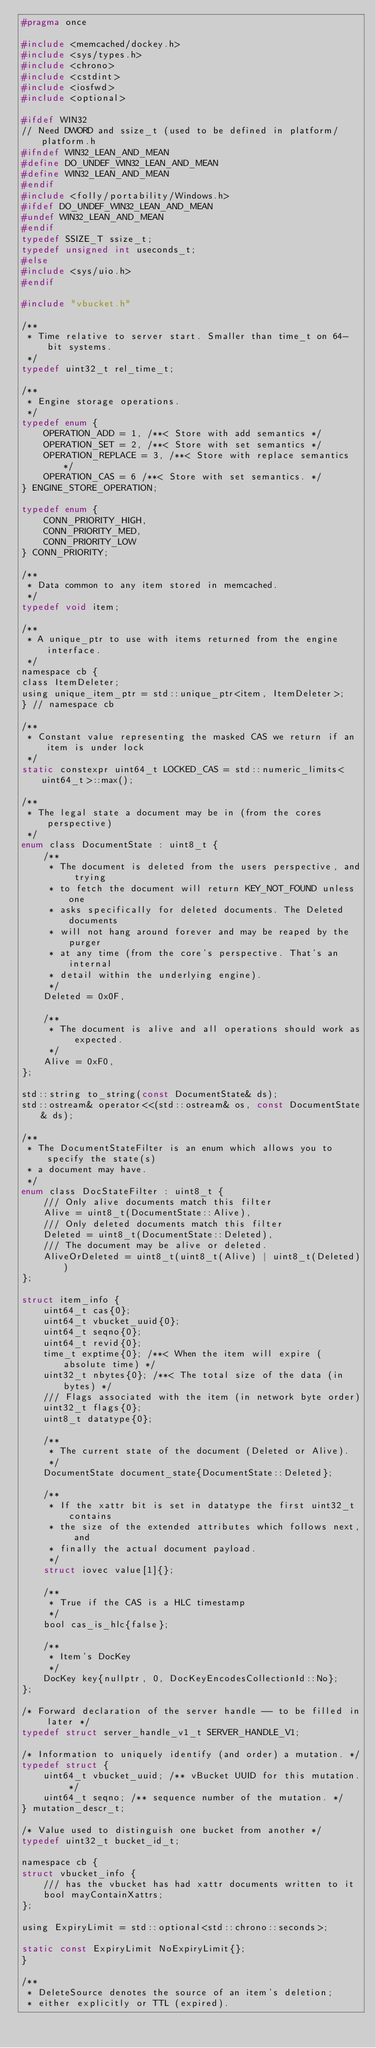Convert code to text. <code><loc_0><loc_0><loc_500><loc_500><_C_>#pragma once

#include <memcached/dockey.h>
#include <sys/types.h>
#include <chrono>
#include <cstdint>
#include <iosfwd>
#include <optional>

#ifdef WIN32
// Need DWORD and ssize_t (used to be defined in platform/platform.h
#ifndef WIN32_LEAN_AND_MEAN
#define DO_UNDEF_WIN32_LEAN_AND_MEAN
#define WIN32_LEAN_AND_MEAN
#endif
#include <folly/portability/Windows.h>
#ifdef DO_UNDEF_WIN32_LEAN_AND_MEAN
#undef WIN32_LEAN_AND_MEAN
#endif
typedef SSIZE_T ssize_t;
typedef unsigned int useconds_t;
#else
#include <sys/uio.h>
#endif

#include "vbucket.h"

/**
 * Time relative to server start. Smaller than time_t on 64-bit systems.
 */
typedef uint32_t rel_time_t;

/**
 * Engine storage operations.
 */
typedef enum {
    OPERATION_ADD = 1, /**< Store with add semantics */
    OPERATION_SET = 2, /**< Store with set semantics */
    OPERATION_REPLACE = 3, /**< Store with replace semantics */
    OPERATION_CAS = 6 /**< Store with set semantics. */
} ENGINE_STORE_OPERATION;

typedef enum {
    CONN_PRIORITY_HIGH,
    CONN_PRIORITY_MED,
    CONN_PRIORITY_LOW
} CONN_PRIORITY;

/**
 * Data common to any item stored in memcached.
 */
typedef void item;

/**
 * A unique_ptr to use with items returned from the engine interface.
 */
namespace cb {
class ItemDeleter;
using unique_item_ptr = std::unique_ptr<item, ItemDeleter>;
} // namespace cb

/**
 * Constant value representing the masked CAS we return if an item is under lock
 */
static constexpr uint64_t LOCKED_CAS = std::numeric_limits<uint64_t>::max();

/**
 * The legal state a document may be in (from the cores perspective)
 */
enum class DocumentState : uint8_t {
    /**
     * The document is deleted from the users perspective, and trying
     * to fetch the document will return KEY_NOT_FOUND unless one
     * asks specifically for deleted documents. The Deleted documents
     * will not hang around forever and may be reaped by the purger
     * at any time (from the core's perspective. That's an internal
     * detail within the underlying engine).
     */
    Deleted = 0x0F,

    /**
     * The document is alive and all operations should work as expected.
     */
    Alive = 0xF0,
};

std::string to_string(const DocumentState& ds);
std::ostream& operator<<(std::ostream& os, const DocumentState& ds);

/**
 * The DocumentStateFilter is an enum which allows you to specify the state(s)
 * a document may have.
 */
enum class DocStateFilter : uint8_t {
    /// Only alive documents match this filter
    Alive = uint8_t(DocumentState::Alive),
    /// Only deleted documents match this filter
    Deleted = uint8_t(DocumentState::Deleted),
    /// The document may be alive or deleted.
    AliveOrDeleted = uint8_t(uint8_t(Alive) | uint8_t(Deleted))
};

struct item_info {
    uint64_t cas{0};
    uint64_t vbucket_uuid{0};
    uint64_t seqno{0};
    uint64_t revid{0};
    time_t exptime{0}; /**< When the item will expire (absolute time) */
    uint32_t nbytes{0}; /**< The total size of the data (in bytes) */
    /// Flags associated with the item (in network byte order)
    uint32_t flags{0};
    uint8_t datatype{0};

    /**
     * The current state of the document (Deleted or Alive).
     */
    DocumentState document_state{DocumentState::Deleted};

    /**
     * If the xattr bit is set in datatype the first uint32_t contains
     * the size of the extended attributes which follows next, and
     * finally the actual document payload.
     */
    struct iovec value[1]{};

    /**
     * True if the CAS is a HLC timestamp
     */
    bool cas_is_hlc{false};

    /**
     * Item's DocKey
     */
    DocKey key{nullptr, 0, DocKeyEncodesCollectionId::No};
};

/* Forward declaration of the server handle -- to be filled in later */
typedef struct server_handle_v1_t SERVER_HANDLE_V1;

/* Information to uniquely identify (and order) a mutation. */
typedef struct {
    uint64_t vbucket_uuid; /** vBucket UUID for this mutation. */
    uint64_t seqno; /** sequence number of the mutation. */
} mutation_descr_t;

/* Value used to distinguish one bucket from another */
typedef uint32_t bucket_id_t;

namespace cb {
struct vbucket_info {
    /// has the vbucket has had xattr documents written to it
    bool mayContainXattrs;
};

using ExpiryLimit = std::optional<std::chrono::seconds>;

static const ExpiryLimit NoExpiryLimit{};
}

/**
 * DeleteSource denotes the source of an item's deletion;
 * either explicitly or TTL (expired).</code> 